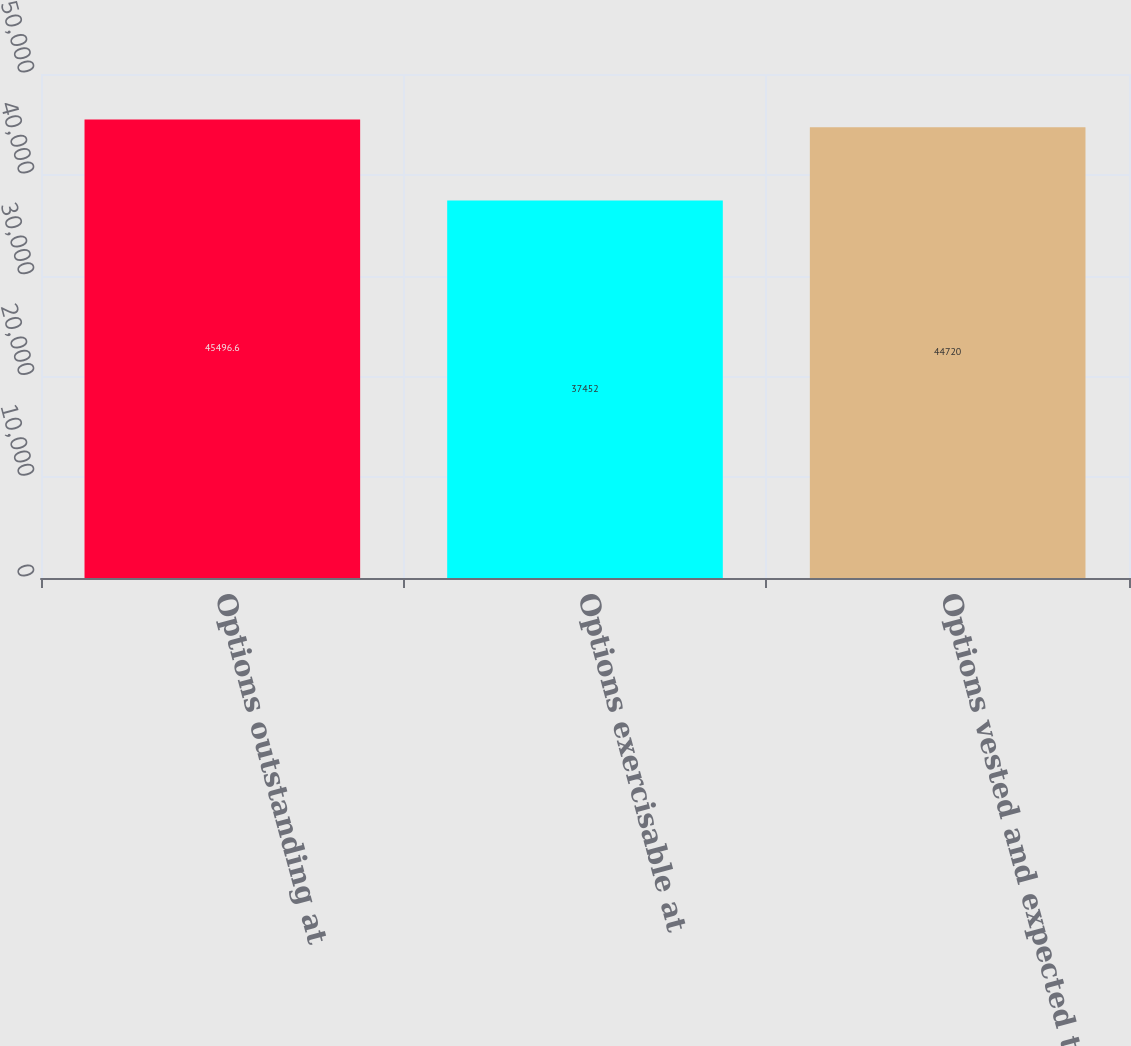<chart> <loc_0><loc_0><loc_500><loc_500><bar_chart><fcel>Options outstanding at<fcel>Options exercisable at<fcel>Options vested and expected to<nl><fcel>45496.6<fcel>37452<fcel>44720<nl></chart> 